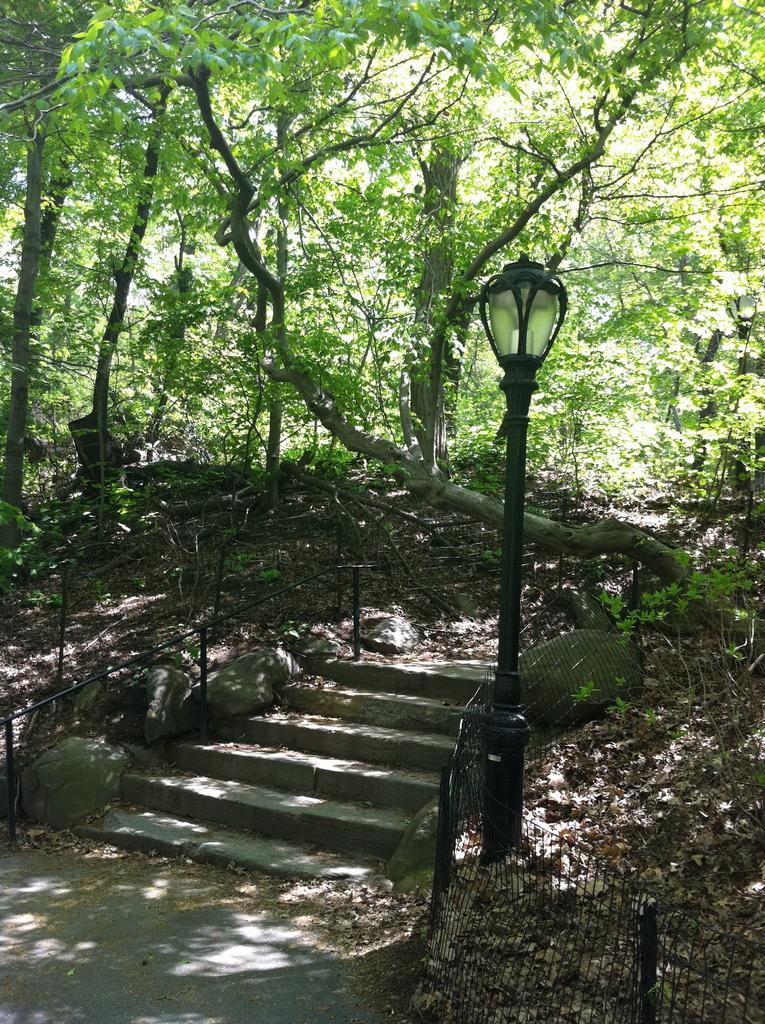What type of structure is present in the image? There are stairs in the image. What else can be seen in the image besides the stairs? There is fencing and a pole with a light in the image. What is the purpose of the pole with a light? The pole with a light is likely for illumination purposes. What can be seen in the background of the image? A group of trees is visible behind the stairs. What type of advertisement can be seen on the stairs in the image? There is no advertisement present on the stairs in the image. 